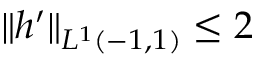Convert formula to latex. <formula><loc_0><loc_0><loc_500><loc_500>\| h ^ { \prime } \| _ { L ^ { 1 } ( - 1 , 1 ) } \leq 2</formula> 